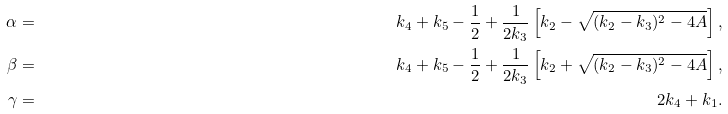<formula> <loc_0><loc_0><loc_500><loc_500>\alpha & = & k _ { 4 } + k _ { 5 } - \frac { 1 } { 2 } + \frac { 1 } { 2 k _ { 3 } } \left [ k _ { 2 } - \sqrt { ( k _ { 2 } - k _ { 3 } ) ^ { 2 } - 4 A } \right ] , \\ \beta & = & k _ { 4 } + k _ { 5 } - \frac { 1 } { 2 } + \frac { 1 } { 2 k _ { 3 } } \left [ k _ { 2 } + \sqrt { ( k _ { 2 } - k _ { 3 } ) ^ { 2 } - 4 A } \right ] , \\ \gamma & = & 2 k _ { 4 } + k _ { 1 } .</formula> 